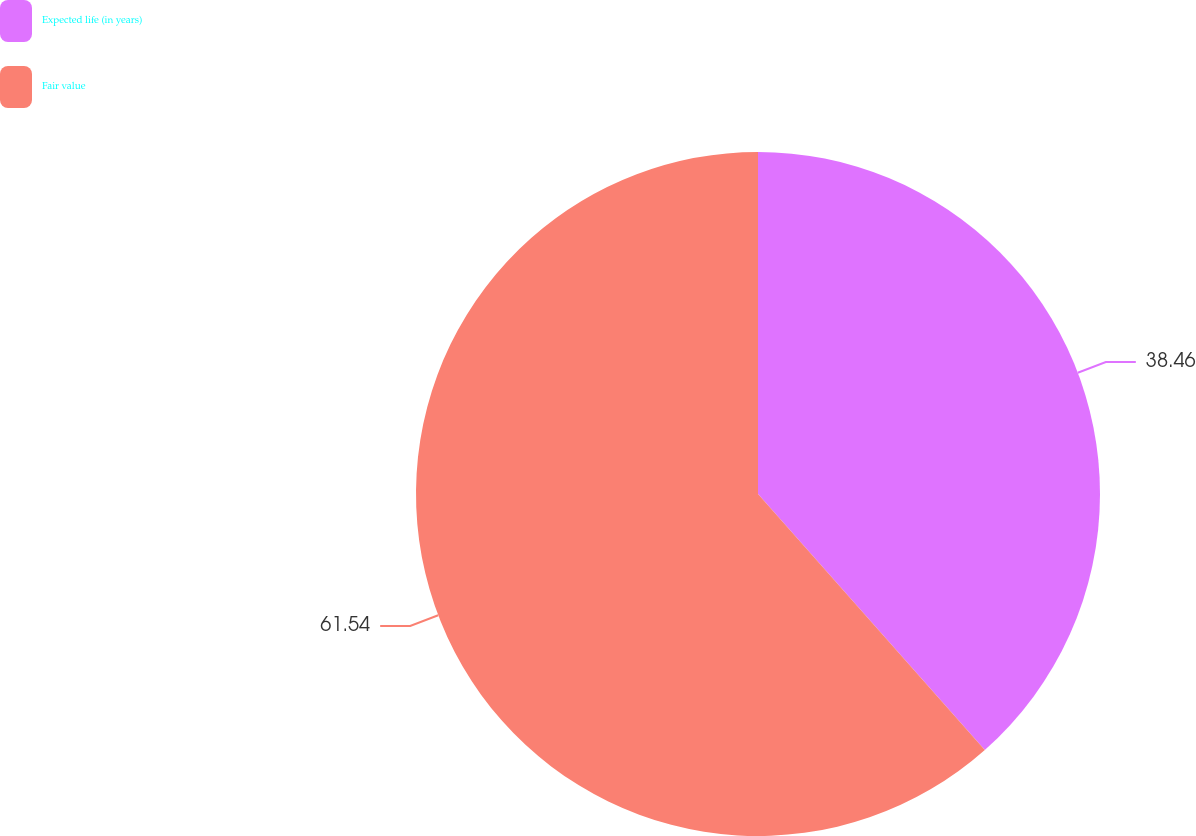Convert chart. <chart><loc_0><loc_0><loc_500><loc_500><pie_chart><fcel>Expected life (in years)<fcel>Fair value<nl><fcel>38.46%<fcel>61.54%<nl></chart> 